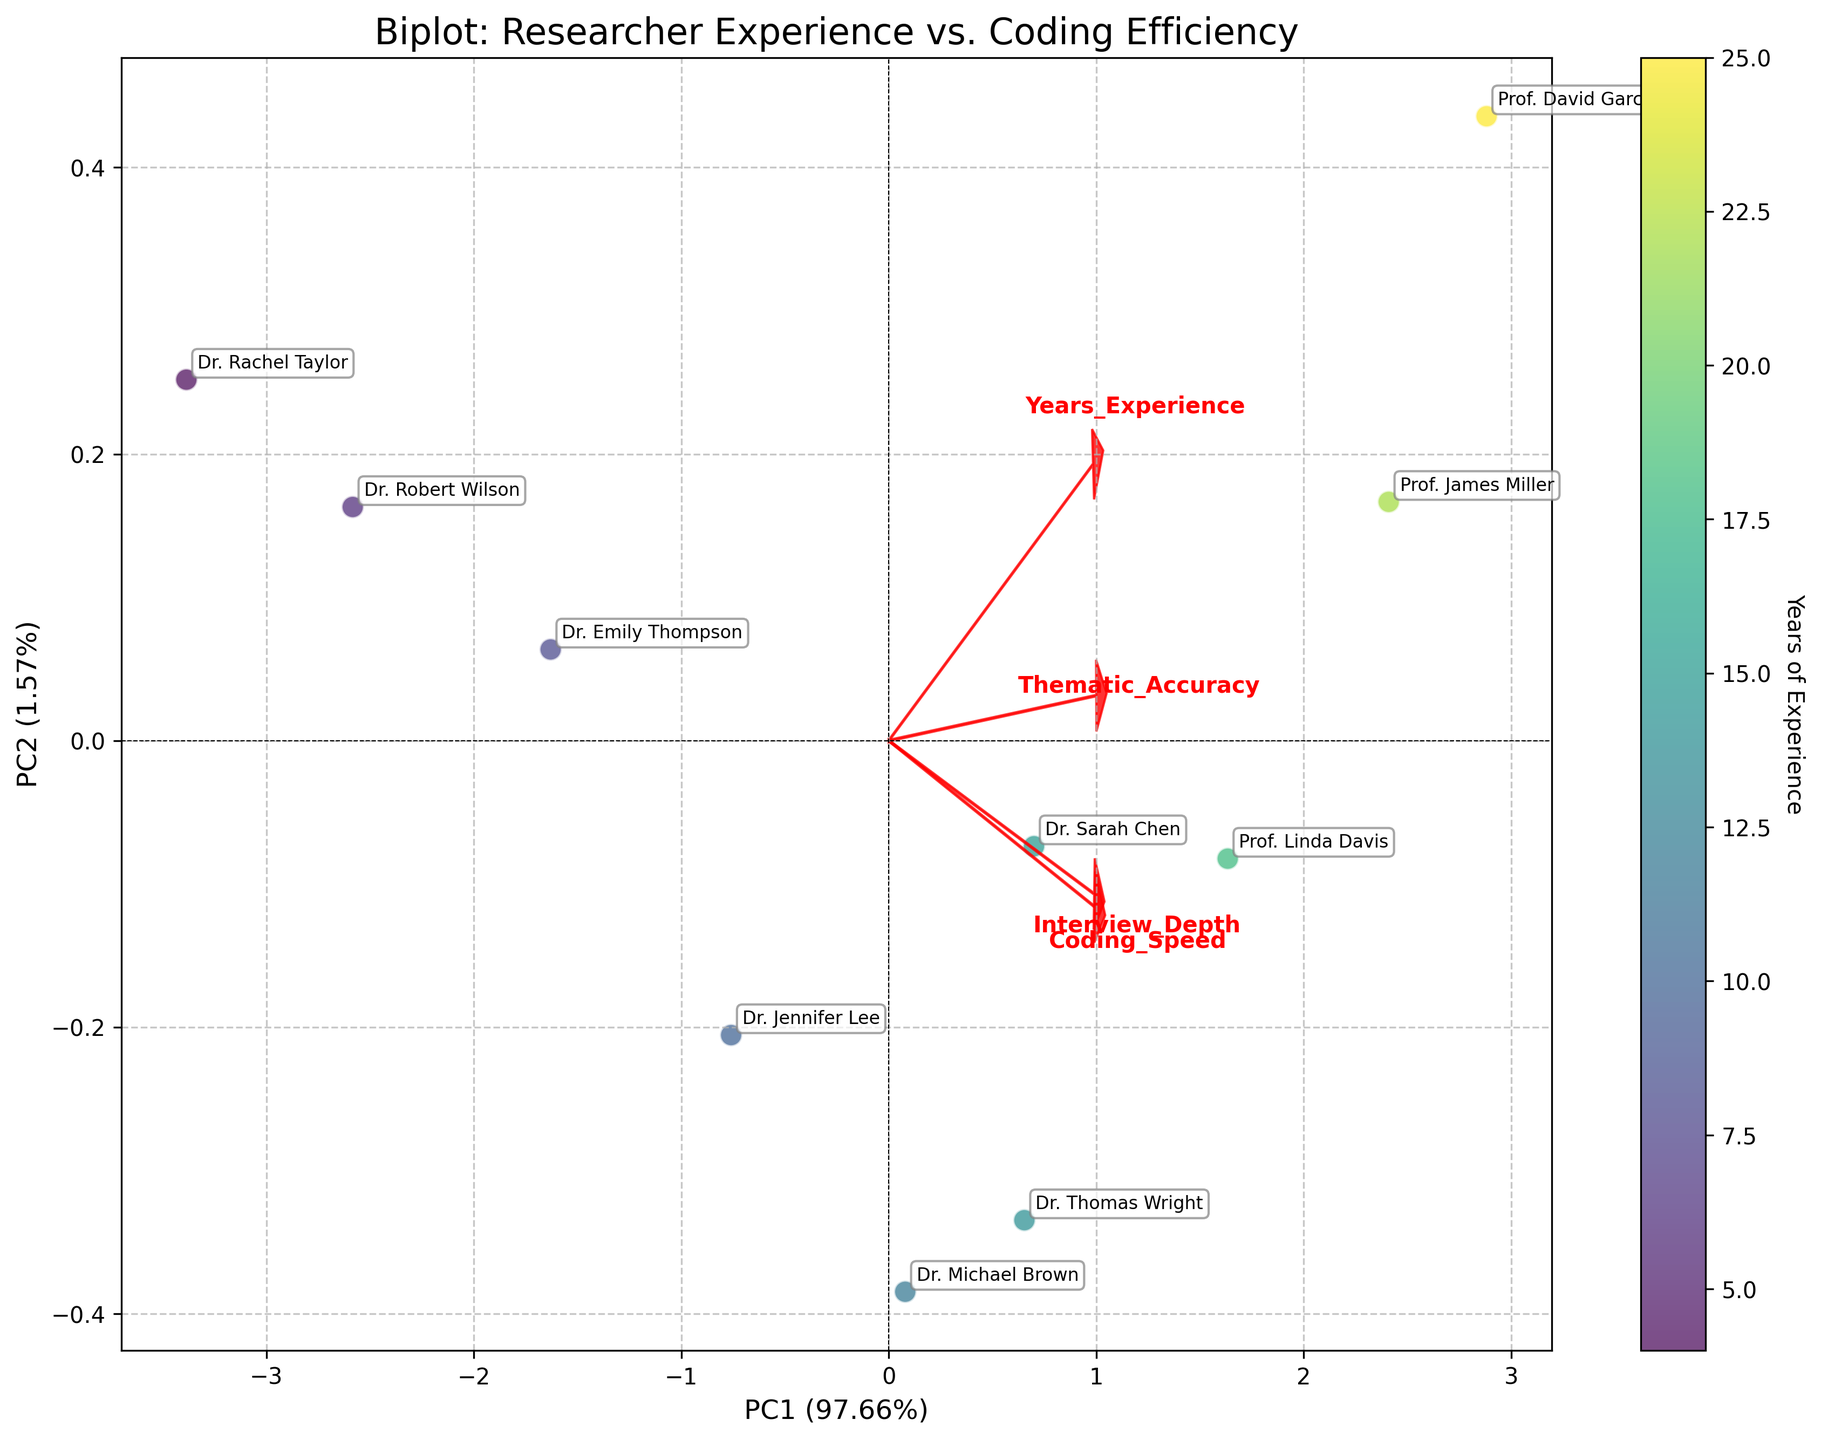What does the color gradient on the data points represent? The color gradient on the data points represents the 'Years of Experience' of the researchers. This is indicated by the colorbar on the right side of the plot, where the spectrum from lighter to darker hues corresponds to fewer to more years of experience, respectively.
Answer: Years of Experience Which researcher has the highest 'Years of Experience'? We can identify the researcher with the highest 'Years of Experience' by looking at the data point with the darkest color. Referring to the annotations, the darkest point is labeled as 'Prof. David Garcia'.
Answer: Prof. David Garcia What do the red arrows on the plot represent? The red arrows represent the loading vectors of the principal component analysis (PCA). Each arrow corresponds to a different feature (e.g., 'Years_Experience', 'Coding_Speed', 'Thematic_Accuracy', 'Interview_Depth'), indicating the direction and magnitude of that variable's contribution to the principal components.
Answer: Loading vectors of features Who has the highest 'Coding_Speed' and where are they positioned on the plot? We first locate the researcher with the highest 'Coding_Speed' from the dataset, which is 'Prof. David Garcia' with a value of 9.9. On the plot, 'Prof. David Garcia' is positioned furthest to the right.
Answer: Prof. David Garcia, furthest right Among 'Dr. Rachel Taylor' and 'Dr. Robert Wilson', who has better 'Thematic_Accuracy'? By checking the dataset for 'Thematic_Accuracy', 'Dr. Robert Wilson' has a slightly higher 'Thematic_Accuracy' (7.2) compared to 'Dr. Rachel Taylor' (6.8). Their respective positions on the plot show 'Dr. Robert Wilson' slightly above 'Dr. Rachel Taylor'.
Answer: Dr. Robert Wilson What is the relationship between 'Years_Experience' and 'Interview_Depth' as indicated by the red arrow? The red arrow corresponding to 'Interview_Depth' points in the same general direction as the arrow for 'Years_Experience', suggesting a positive relationship between the two variables. This means individuals with more years of experience tend to conduct deeper interviews.
Answer: Positive relationship Is there any researcher positioned near the origin of the plot? Researchers near the origin of the plot have average values in the principal components. 'Dr. Jennifer Lee' is positioned nearest to the origin, indicating her data values are closest to the mean in both components.
Answer: Dr. Jennifer Lee Who are the researchers associated with NVivo software and where are they located on the plot? According to the dataset, 'Dr. Sarah Chen' and 'Dr. Jennifer Lee' are associated with NVivo software. 'Dr. Sarah Chen' is positioned in the top right quadrant, while 'Dr. Jennifer Lee' is near the origin.
Answer: Dr. Sarah Chen and Dr. Jennifer Lee Which feature has the largest influence on PC1? The largest influence on PC1 can be determined by the length of the red arrow along the PC1 axis. The 'Years_Experience' arrow is the longest along PC1, indicating it has the largest influence on this principal component.
Answer: Years_Experience What percentage of variance is explained by PC1 and PC2 combined? The percentage of variance explained by each principal component is usually labeled on the axes. On this plot, PC1 explains 45% of the variance, and PC2 explains 30%. Adding these gives a combined explained variance of 75%.
Answer: 75% 